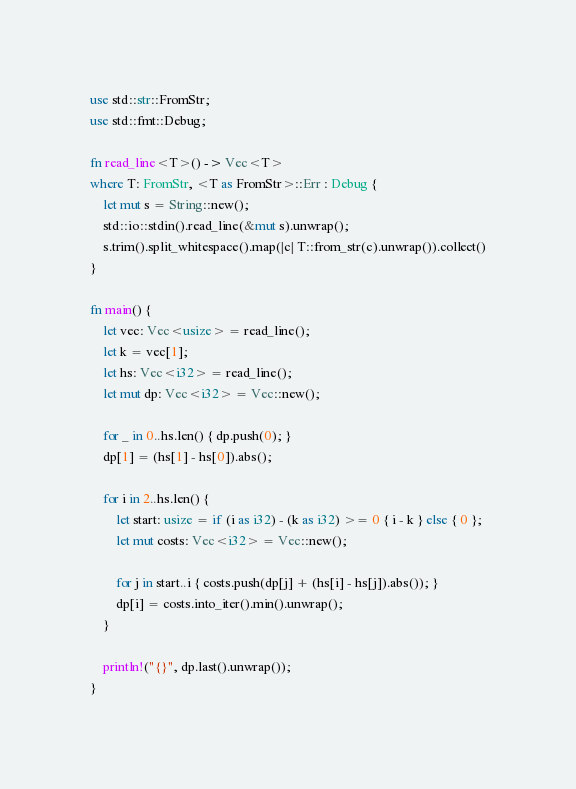Convert code to text. <code><loc_0><loc_0><loc_500><loc_500><_Rust_>use std::str::FromStr;
use std::fmt::Debug;

fn read_line<T>() -> Vec<T>
where T: FromStr, <T as FromStr>::Err : Debug {
    let mut s = String::new();
    std::io::stdin().read_line(&mut s).unwrap();
    s.trim().split_whitespace().map(|c| T::from_str(c).unwrap()).collect()
}

fn main() {
    let vec: Vec<usize> = read_line();
    let k = vec[1];
    let hs: Vec<i32> = read_line();
    let mut dp: Vec<i32> = Vec::new();

    for _ in 0..hs.len() { dp.push(0); }
    dp[1] = (hs[1] - hs[0]).abs();

    for i in 2..hs.len() {
        let start: usize = if (i as i32) - (k as i32) >= 0 { i - k } else { 0 };
        let mut costs: Vec<i32> = Vec::new();

        for j in start..i { costs.push(dp[j] + (hs[i] - hs[j]).abs()); }
        dp[i] = costs.into_iter().min().unwrap();
    }

    println!("{}", dp.last().unwrap());
}</code> 